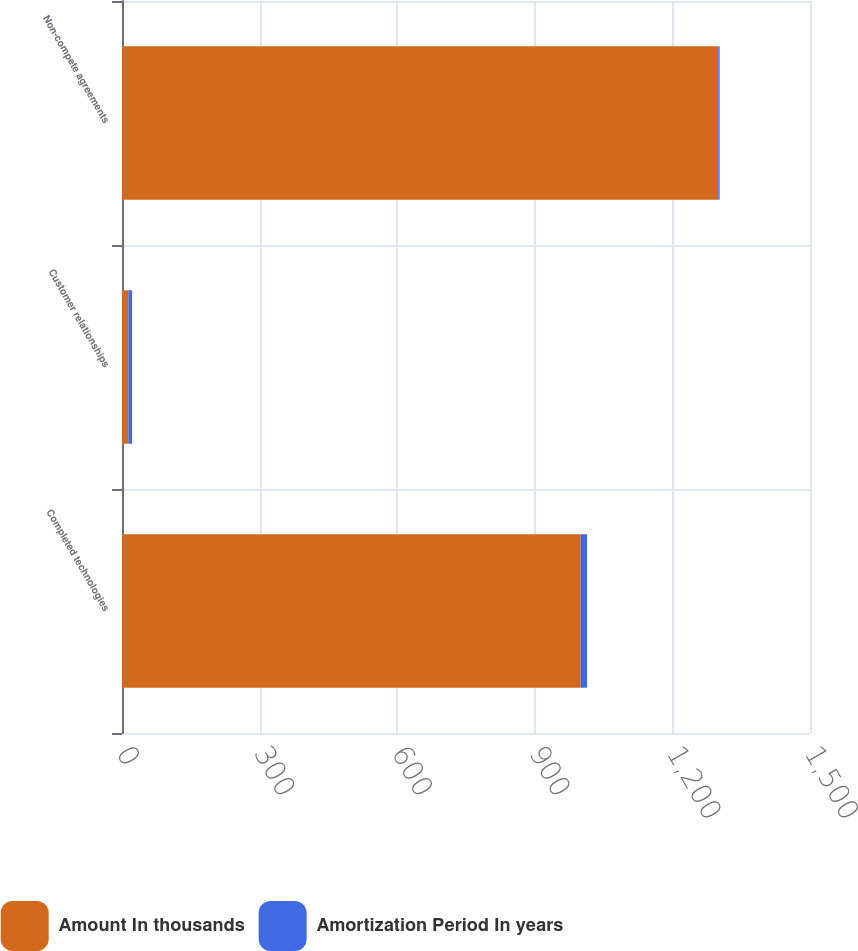Convert chart to OTSL. <chart><loc_0><loc_0><loc_500><loc_500><stacked_bar_chart><ecel><fcel>Completed technologies<fcel>Customer relationships<fcel>Non-compete agreements<nl><fcel>Amount In thousands<fcel>1000<fcel>14<fcel>1300<nl><fcel>Amortization Period In years<fcel>14<fcel>8<fcel>3<nl></chart> 